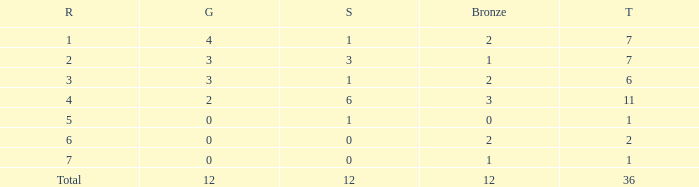What is the largest total for a team with fewer than 12 bronze, 1 silver and 0 gold medals? 1.0. 